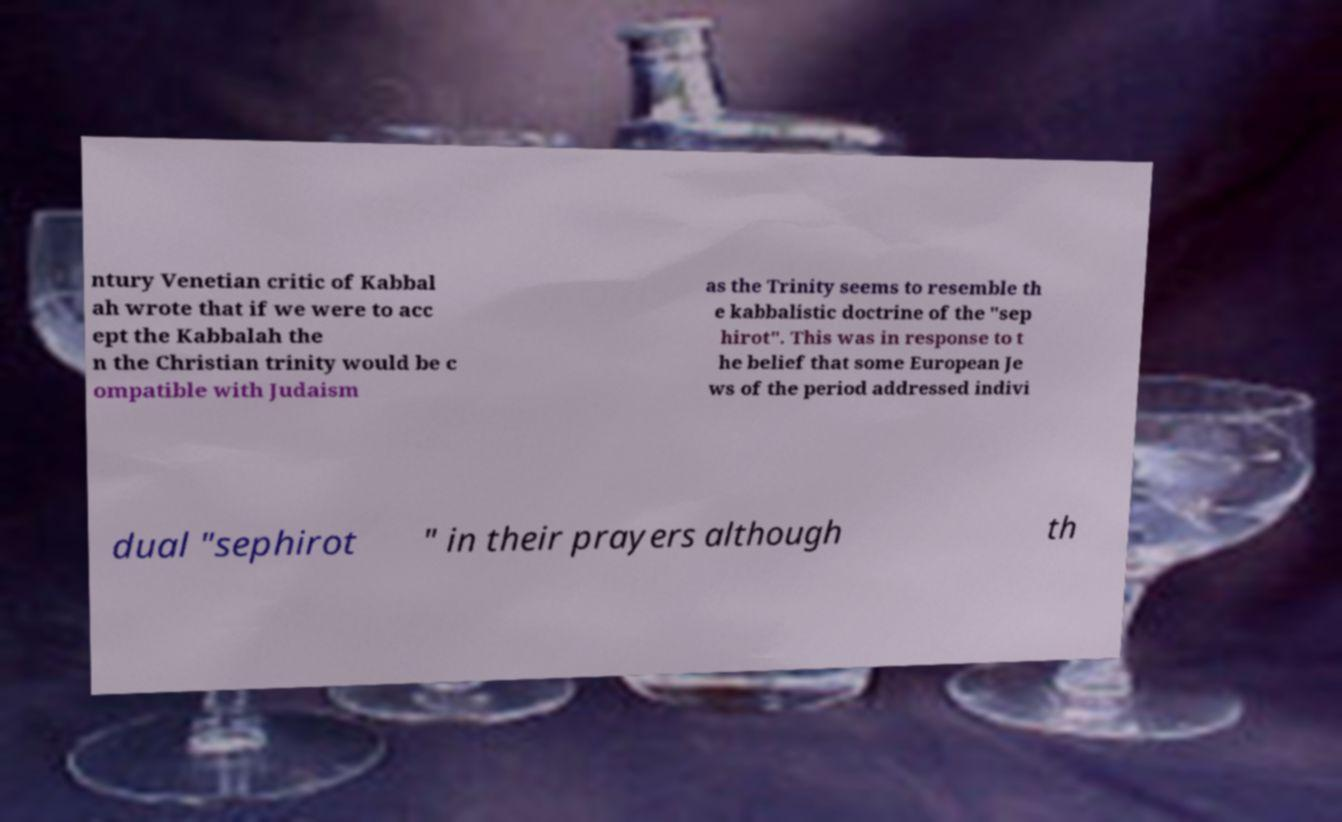Can you read and provide the text displayed in the image?This photo seems to have some interesting text. Can you extract and type it out for me? ntury Venetian critic of Kabbal ah wrote that if we were to acc ept the Kabbalah the n the Christian trinity would be c ompatible with Judaism as the Trinity seems to resemble th e kabbalistic doctrine of the "sep hirot". This was in response to t he belief that some European Je ws of the period addressed indivi dual "sephirot " in their prayers although th 